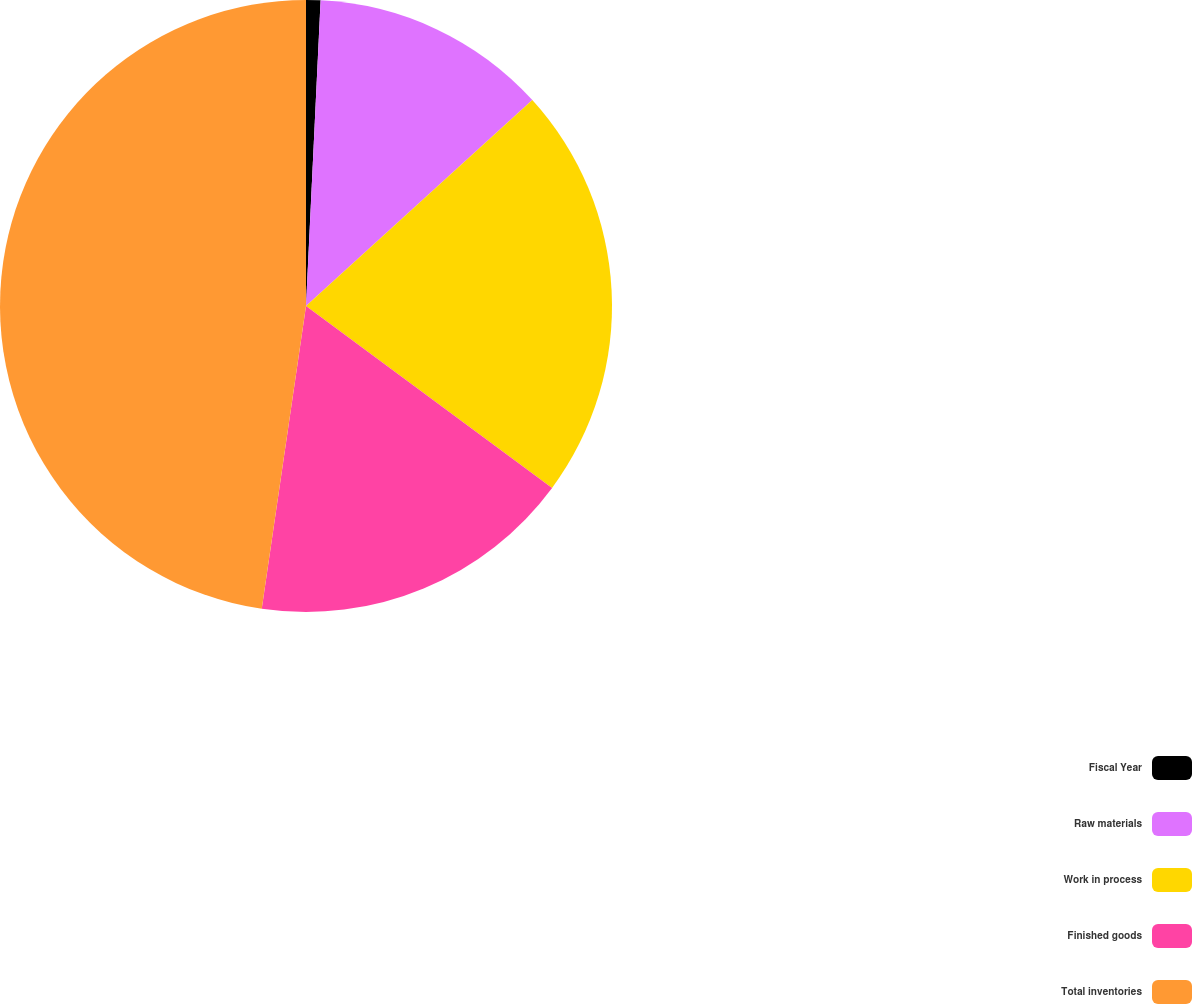Convert chart to OTSL. <chart><loc_0><loc_0><loc_500><loc_500><pie_chart><fcel>Fiscal Year<fcel>Raw materials<fcel>Work in process<fcel>Finished goods<fcel>Total inventories<nl><fcel>0.76%<fcel>12.49%<fcel>21.88%<fcel>17.18%<fcel>47.69%<nl></chart> 